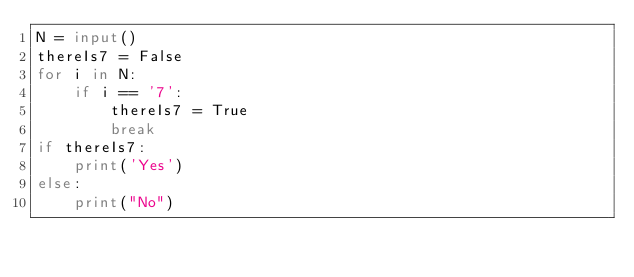<code> <loc_0><loc_0><loc_500><loc_500><_Python_>N = input()
thereIs7 = False
for i in N:
    if i == '7':
        thereIs7 = True
        break
if thereIs7:
    print('Yes')
else:
    print("No")</code> 